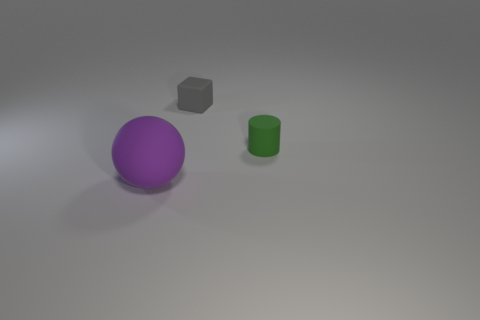Add 3 small gray rubber things. How many objects exist? 6 Subtract all cubes. How many objects are left? 2 Add 1 gray things. How many gray things are left? 2 Add 1 large metallic objects. How many large metallic objects exist? 1 Subtract 0 yellow spheres. How many objects are left? 3 Subtract all purple rubber balls. Subtract all purple spheres. How many objects are left? 1 